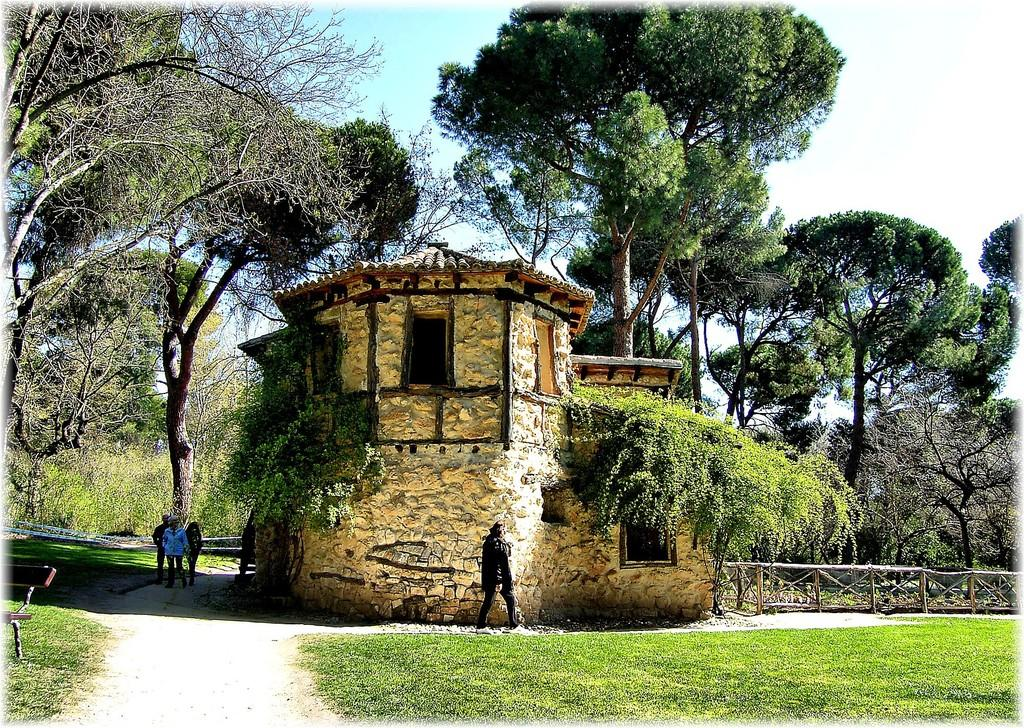What are the persons in the image doing? The persons in the image are walking on the ground. What can be seen in the background of the image? There is a house, trees, plants, and fences in the background. What type of vegetation is present on the ground? There is grass on the ground. What is visible in the sky in the image? There are clouds in the sky. What type of vessel is being used to water the plants in the image? There is no vessel or watering activity present in the image. Can you tell me how many earthworms are visible in the image? There are no earthworms visible in the image. 